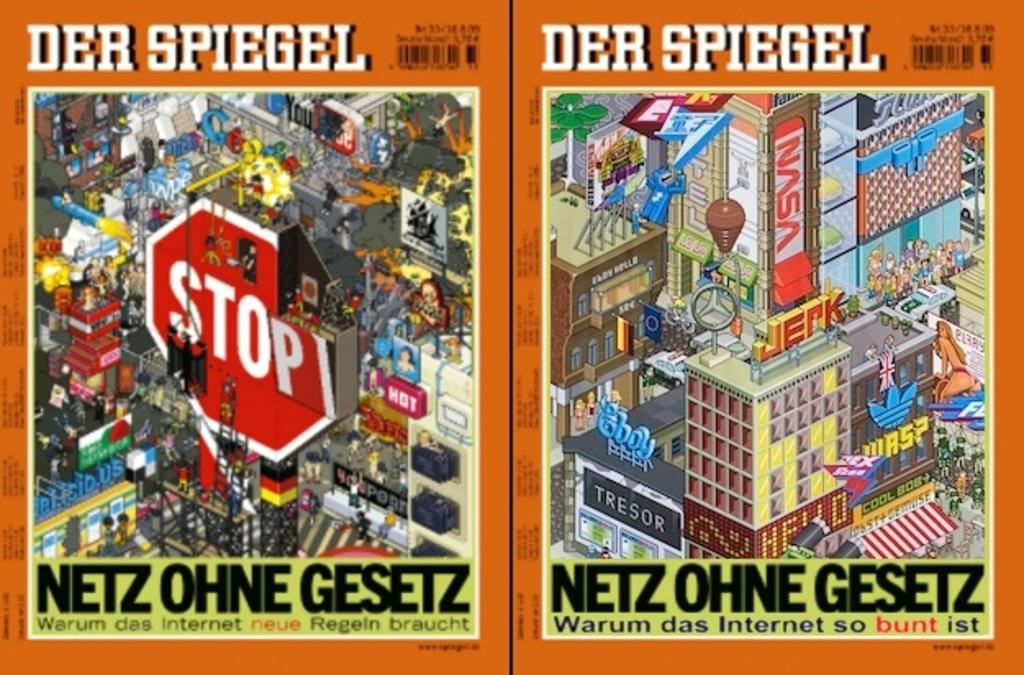Provide a one-sentence caption for the provided image. A magazine cover in German with a Stop sign on one side. 